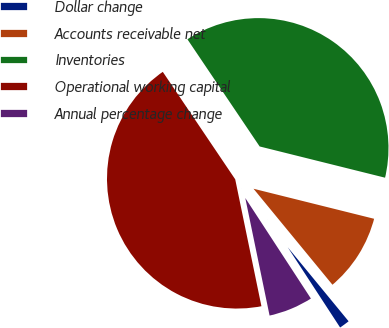Convert chart. <chart><loc_0><loc_0><loc_500><loc_500><pie_chart><fcel>Dollar change<fcel>Accounts receivable net<fcel>Inventories<fcel>Operational working capital<fcel>Annual percentage change<nl><fcel>1.75%<fcel>10.16%<fcel>38.32%<fcel>43.8%<fcel>5.96%<nl></chart> 